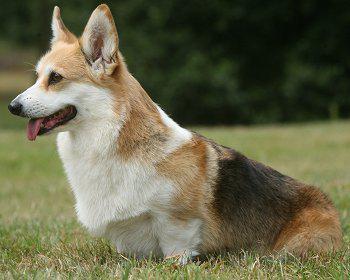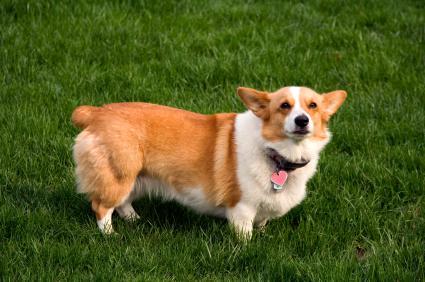The first image is the image on the left, the second image is the image on the right. Analyze the images presented: Is the assertion "In the left image there is a dog with its front paw up." valid? Answer yes or no. No. 